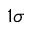Convert formula to latex. <formula><loc_0><loc_0><loc_500><loc_500>1 \sigma</formula> 